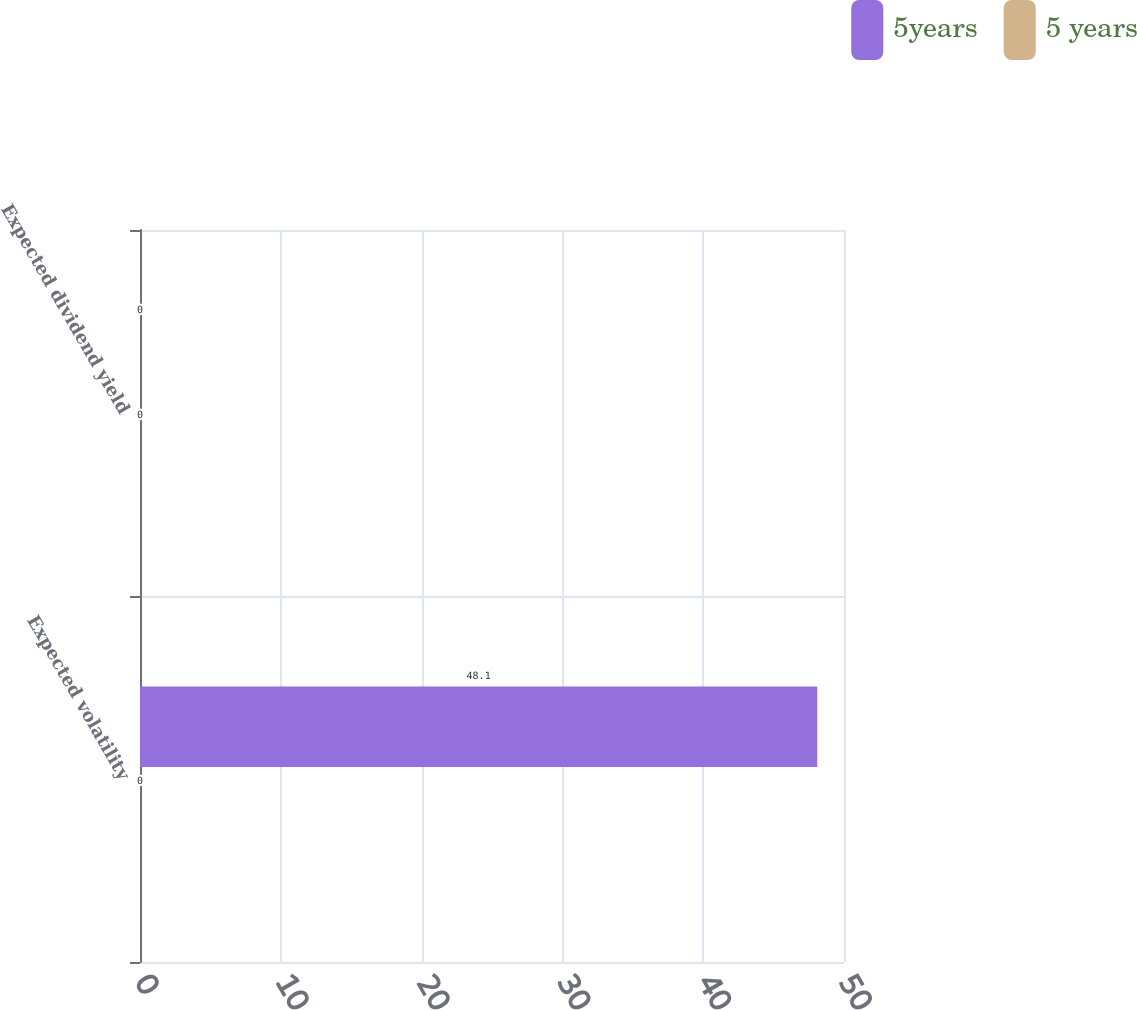Convert chart. <chart><loc_0><loc_0><loc_500><loc_500><stacked_bar_chart><ecel><fcel>Expected volatility<fcel>Expected dividend yield<nl><fcel>5years<fcel>48.1<fcel>0<nl><fcel>5 years<fcel>0<fcel>0<nl></chart> 